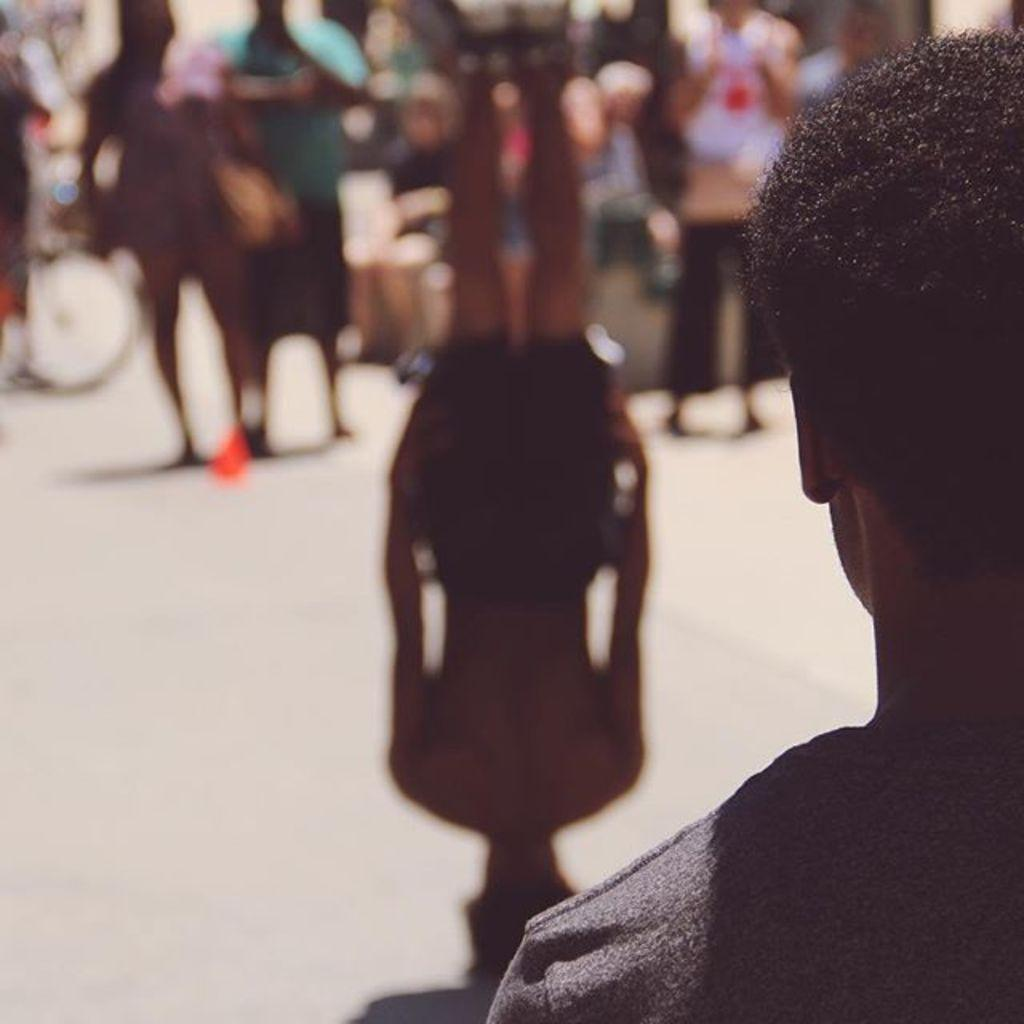What is happening with the person who has their head on the ground and legs up? One person in the image has their head on the ground and legs up, which suggests they might be lying down or relaxing. How many people are visible in the image? There are people standing in the image, but the exact number is not specified. What can be observed about the background of the image? The background of the image is blurry. What type of stove can be seen in the image? There is no stove present in the image. How many rabbits are visible in the image? There are no rabbits visible in the image. 